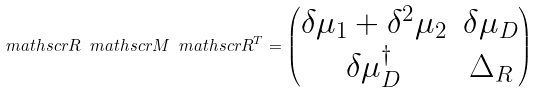<formula> <loc_0><loc_0><loc_500><loc_500>\ m a t h s c r { R } \ m a t h s c r { M } \ m a t h s c r { R } ^ { T } = \begin{pmatrix} \delta \mu _ { 1 } + \delta ^ { 2 } \mu _ { 2 } & \delta \mu _ { D } \\ \delta \mu _ { D } ^ { \dagger } & \Delta _ { R } \end{pmatrix}</formula> 